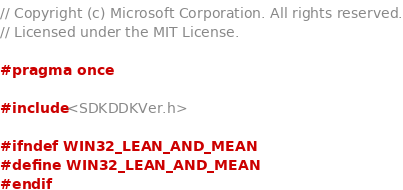<code> <loc_0><loc_0><loc_500><loc_500><_C_>// Copyright (c) Microsoft Corporation. All rights reserved.
// Licensed under the MIT License.

#pragma once

#include <SDKDDKVer.h>

#ifndef WIN32_LEAN_AND_MEAN
#define WIN32_LEAN_AND_MEAN
#endif
</code> 